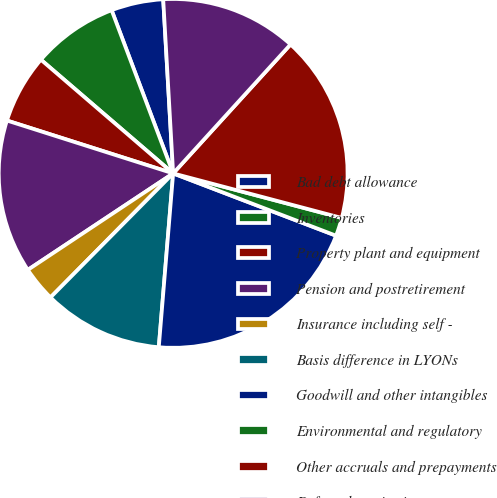Convert chart. <chart><loc_0><loc_0><loc_500><loc_500><pie_chart><fcel>Bad debt allowance<fcel>Inventories<fcel>Property plant and equipment<fcel>Pension and postretirement<fcel>Insurance including self -<fcel>Basis difference in LYONs<fcel>Goodwill and other intangibles<fcel>Environmental and regulatory<fcel>Other accruals and prepayments<fcel>Deferred service income<nl><fcel>4.83%<fcel>7.96%<fcel>6.4%<fcel>14.23%<fcel>3.26%<fcel>11.1%<fcel>20.5%<fcel>1.7%<fcel>17.36%<fcel>12.66%<nl></chart> 